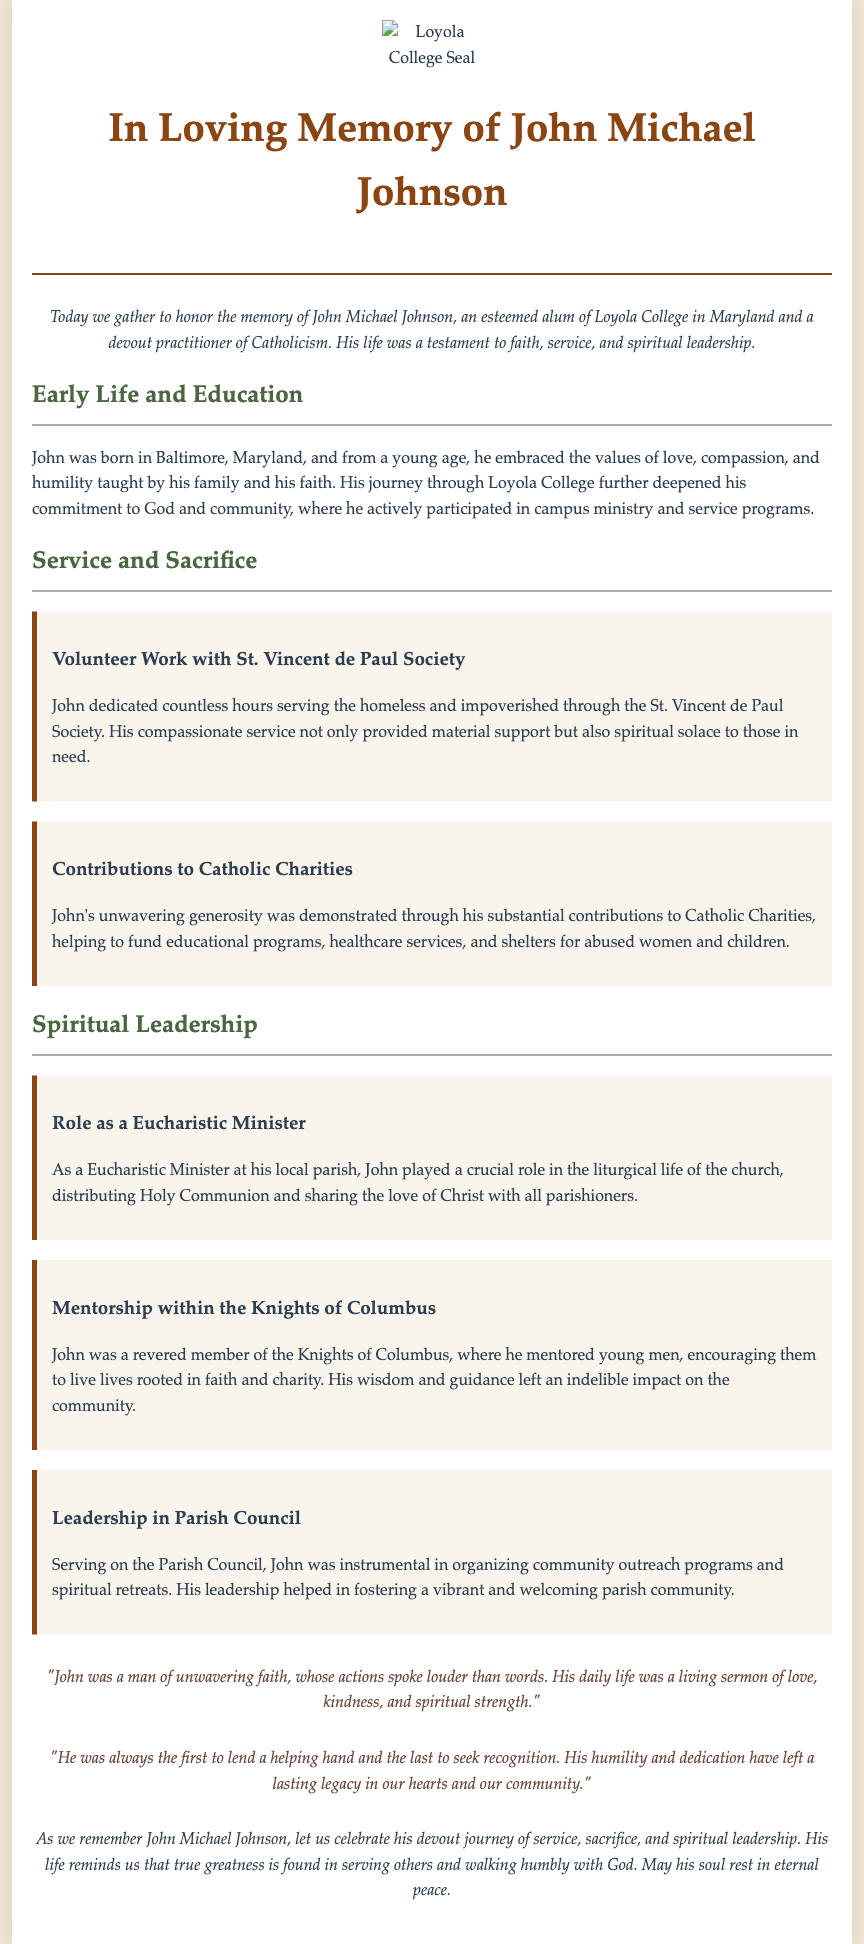What is the full name of the individual being remembered? The document is about honoring John Michael Johnson, as stated in the title and throughout the text.
Answer: John Michael Johnson Where was John born? The document mentions that John was born in Baltimore, Maryland.
Answer: Baltimore, Maryland What organization did John volunteer with? The eulogy highlights John's service with the St. Vincent de Paul Society.
Answer: St. Vincent de Paul Society What role did John serve in his local parish? The document notes that John served as a Eucharistic Minister in his local parish.
Answer: Eucharistic Minister What community organization did John mentor young men within? The eulogy describes John's involvement with the Knights of Columbus, where he mentored young men.
Answer: Knights of Columbus What did John help fund through his contributions? The document states that John contributed to Catholic Charities, which funded educational programs and shelters.
Answer: Educational programs, shelters How is John's character described in the reflections? The reflections emphasize John's unwavering faith, kindness, and humility.
Answer: Unwavering faith, kindness, humility What is emphasized about John's approach to helping others? The document describes John as the first to lend a helping hand and the last to seek recognition, highlighting his humility.
Answer: Humility 